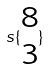Convert formula to latex. <formula><loc_0><loc_0><loc_500><loc_500>s \{ \begin{matrix} 8 \\ 3 \end{matrix} \}</formula> 